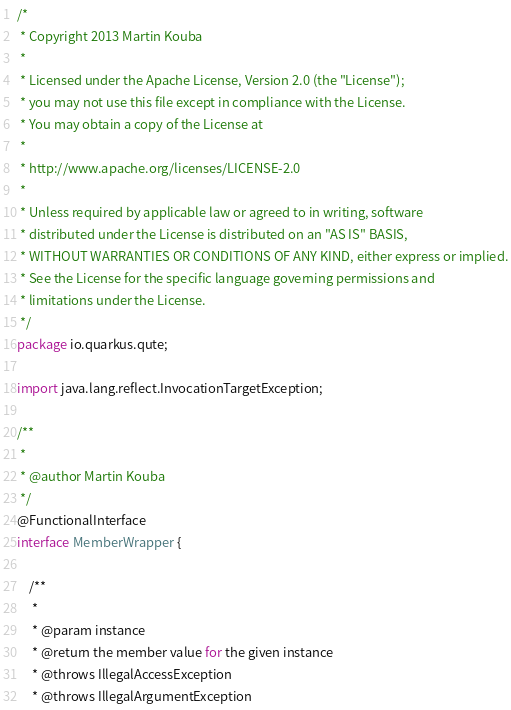<code> <loc_0><loc_0><loc_500><loc_500><_Java_>/*
 * Copyright 2013 Martin Kouba
 *
 * Licensed under the Apache License, Version 2.0 (the "License");
 * you may not use this file except in compliance with the License.
 * You may obtain a copy of the License at
 *
 * http://www.apache.org/licenses/LICENSE-2.0
 *
 * Unless required by applicable law or agreed to in writing, software
 * distributed under the License is distributed on an "AS IS" BASIS,
 * WITHOUT WARRANTIES OR CONDITIONS OF ANY KIND, either express or implied.
 * See the License for the specific language governing permissions and
 * limitations under the License.
 */
package io.quarkus.qute;

import java.lang.reflect.InvocationTargetException;

/**
 *
 * @author Martin Kouba
 */
@FunctionalInterface
interface MemberWrapper {

    /**
     *
     * @param instance
     * @return the member value for the given instance
     * @throws IllegalAccessException
     * @throws IllegalArgumentException</code> 